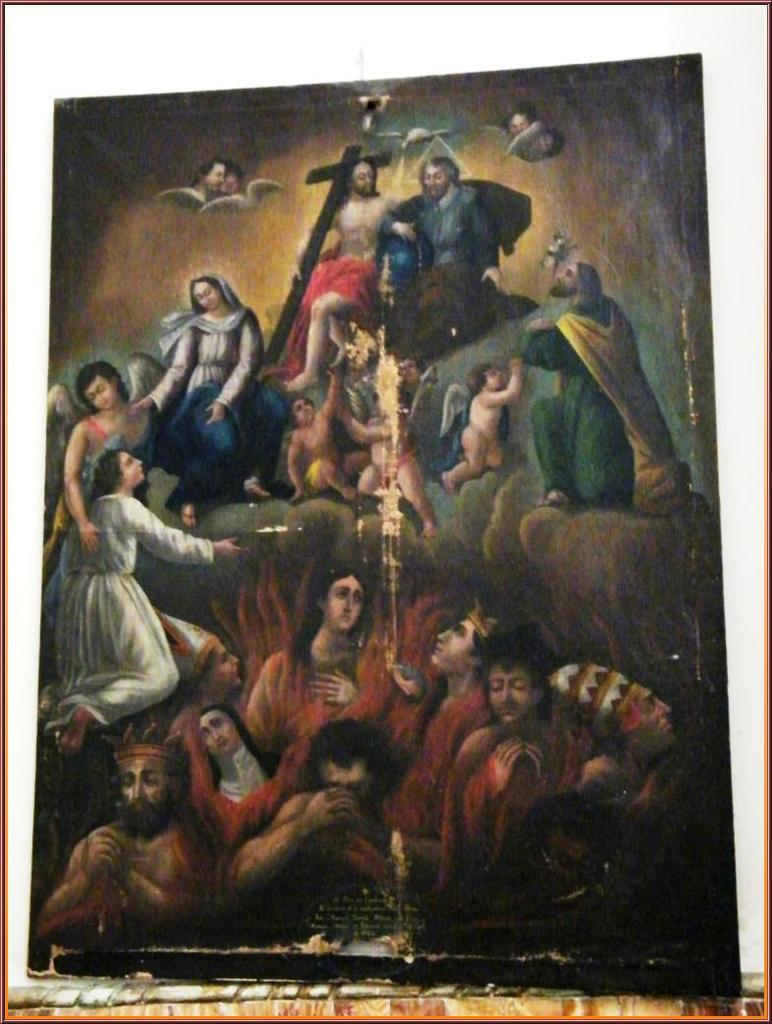What is the main subject of the image? There is a painting in the image. What can be seen within the painting? There are people in the painting. What symbol or object is present at the top of the painting? There is a cross at the top of the painting. How does the wind affect the balloon in the painting? There is no balloon present in the painting, so the wind's effect cannot be determined. What type of prose is written on the painting? There is no prose written on the painting; it is a visual representation. 